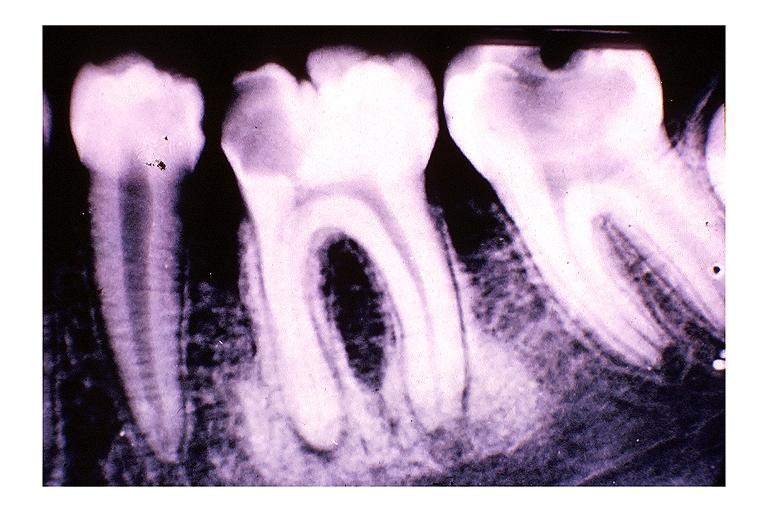what does this image show?
Answer the question using a single word or phrase. Focal sclerosing osteomyelitis condensing osteitis 